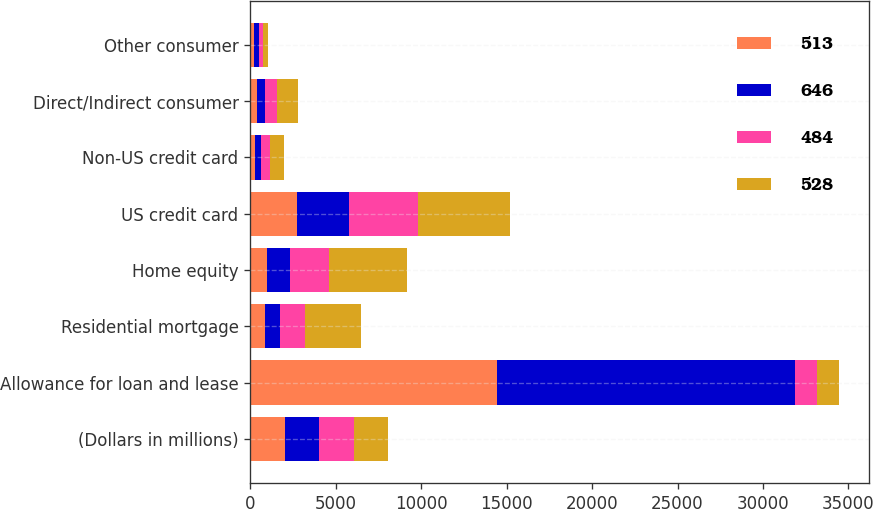Convert chart. <chart><loc_0><loc_0><loc_500><loc_500><stacked_bar_chart><ecel><fcel>(Dollars in millions)<fcel>Allowance for loan and lease<fcel>Residential mortgage<fcel>Home equity<fcel>US credit card<fcel>Non-US credit card<fcel>Direct/Indirect consumer<fcel>Other consumer<nl><fcel>513<fcel>2015<fcel>14419<fcel>866<fcel>975<fcel>2738<fcel>275<fcel>383<fcel>224<nl><fcel>646<fcel>2014<fcel>17428<fcel>855<fcel>1364<fcel>3068<fcel>357<fcel>456<fcel>268<nl><fcel>484<fcel>2013<fcel>1311<fcel>1508<fcel>2258<fcel>4004<fcel>508<fcel>710<fcel>273<nl><fcel>528<fcel>2012<fcel>1311<fcel>3276<fcel>4573<fcel>5360<fcel>835<fcel>1258<fcel>274<nl></chart> 